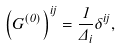<formula> <loc_0><loc_0><loc_500><loc_500>\left ( G ^ { ( 0 ) } \right ) ^ { i j } = \frac { 1 } { \Delta _ { i } } \delta ^ { i j } ,</formula> 